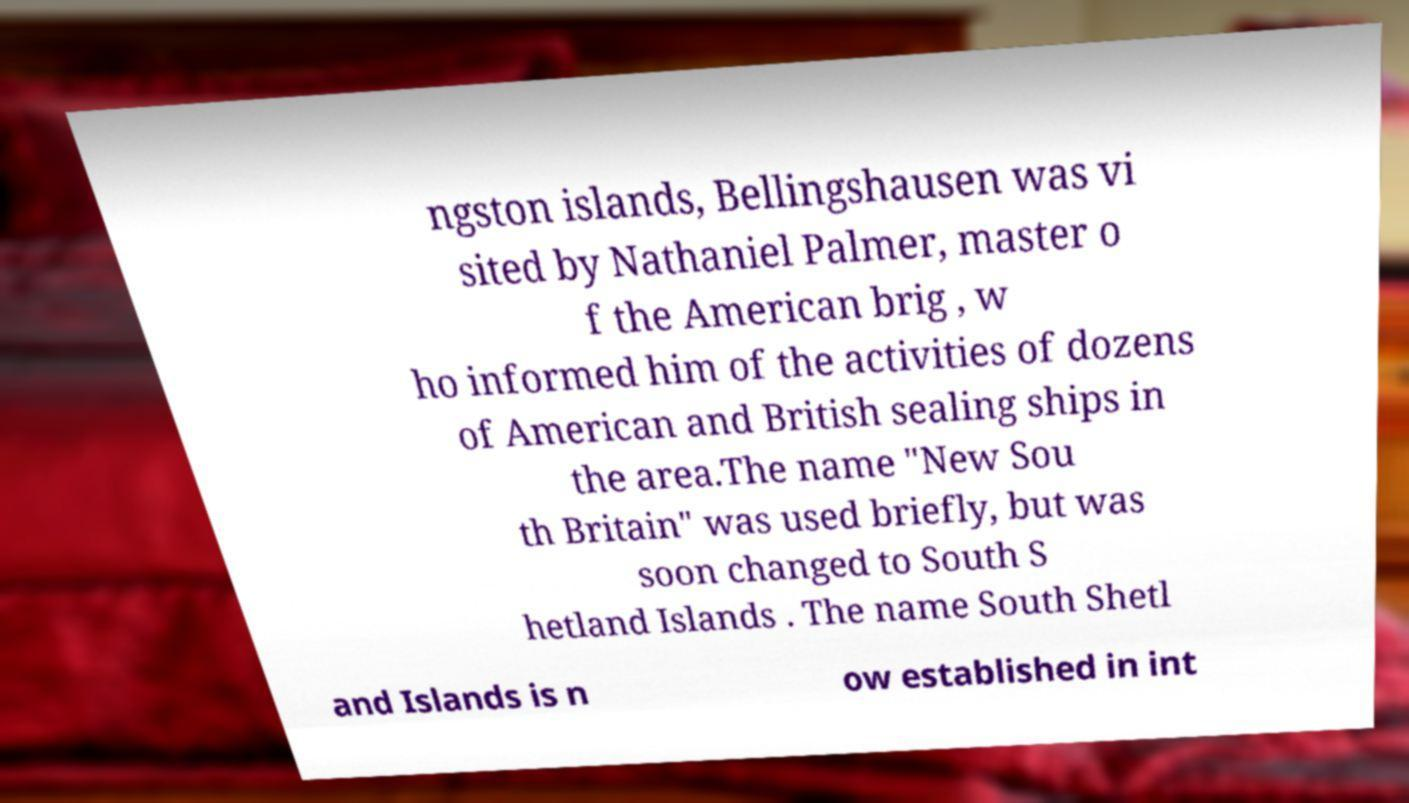Please identify and transcribe the text found in this image. ngston islands, Bellingshausen was vi sited by Nathaniel Palmer, master o f the American brig , w ho informed him of the activities of dozens of American and British sealing ships in the area.The name "New Sou th Britain" was used briefly, but was soon changed to South S hetland Islands . The name South Shetl and Islands is n ow established in int 